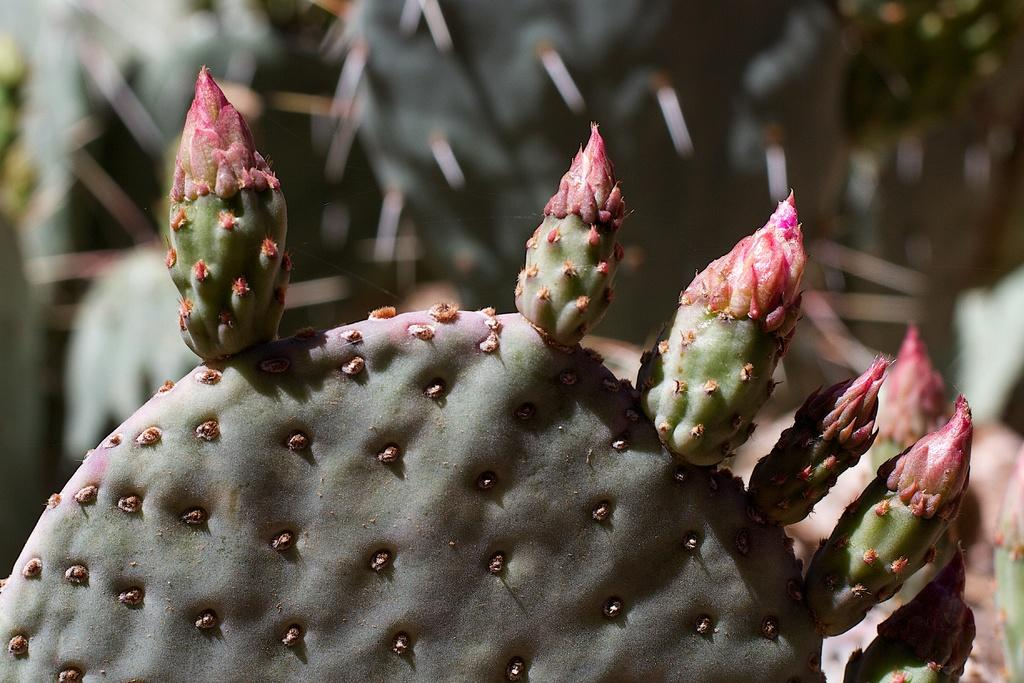What type of plant is featured in the image? There is a pear cactus bud in the image. What type of wire is holding the pear cactus bud in the image? There is no wire present in the image; the pear cactus bud is not being held by any visible support. 